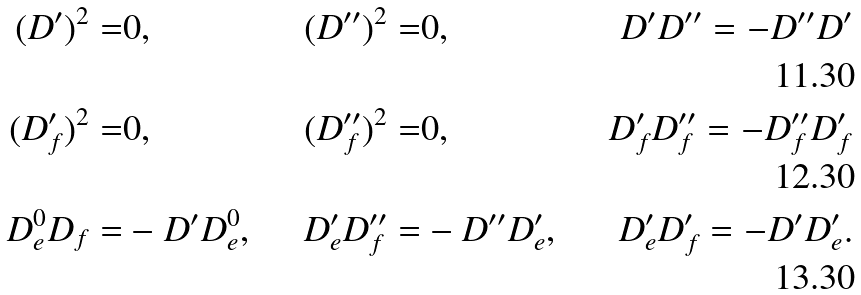<formula> <loc_0><loc_0><loc_500><loc_500>( D ^ { \prime } ) ^ { 2 } = & 0 , \quad & ( D ^ { \prime \prime } ) ^ { 2 } = & 0 , \quad & D ^ { \prime } D ^ { \prime \prime } = - D ^ { \prime \prime } D ^ { \prime } \\ ( D ^ { \prime } _ { f } ) ^ { 2 } = & 0 , \quad & ( D ^ { \prime \prime } _ { f } ) ^ { 2 } = & 0 , \quad & D ^ { \prime } _ { f } D ^ { \prime \prime } _ { f } = - D _ { f } ^ { \prime \prime } D _ { f } ^ { \prime } \\ D ^ { 0 } _ { e } D _ { f } = & - D ^ { \prime } D ^ { 0 } _ { e } , \quad & D ^ { \prime } _ { e } D ^ { \prime \prime } _ { f } = & - D ^ { \prime \prime } D ^ { \prime } _ { e } , \quad & D ^ { \prime } _ { e } D ^ { \prime } _ { f } = - D ^ { \prime } D ^ { \prime } _ { e } .</formula> 